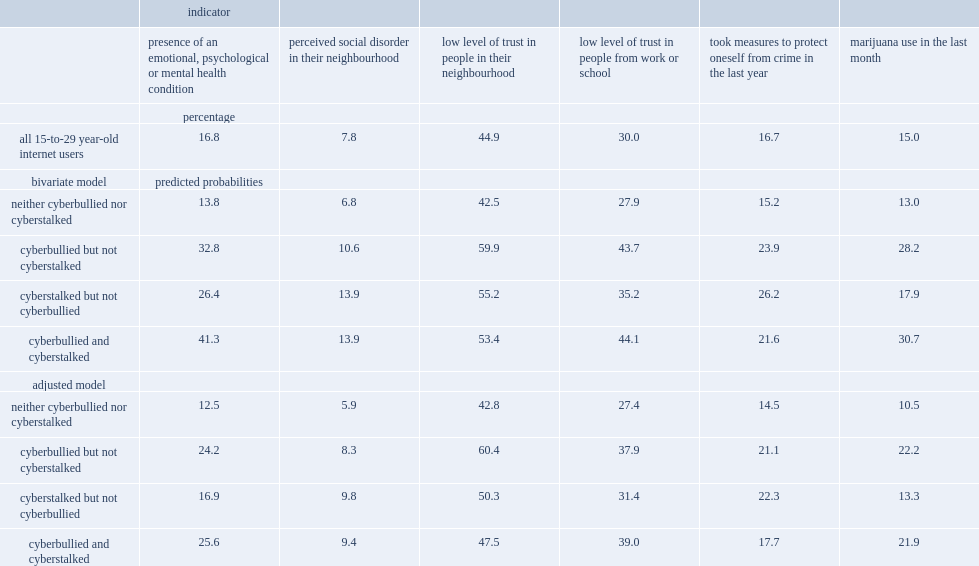What were the percentages of social disorder in the neighbourhood for those who did not experience cyberstalking or cyberbullying? 13.8 6.8. What was the percentage of individuals who were cyberstalked who said they had an emotional, psychological or mental health condition. 26.4. What were the percentages of individuals who were cyberbullied who said they had an emotional, psychological or mental health condition and for those who experienced both respectively? 32.8 41.3. 